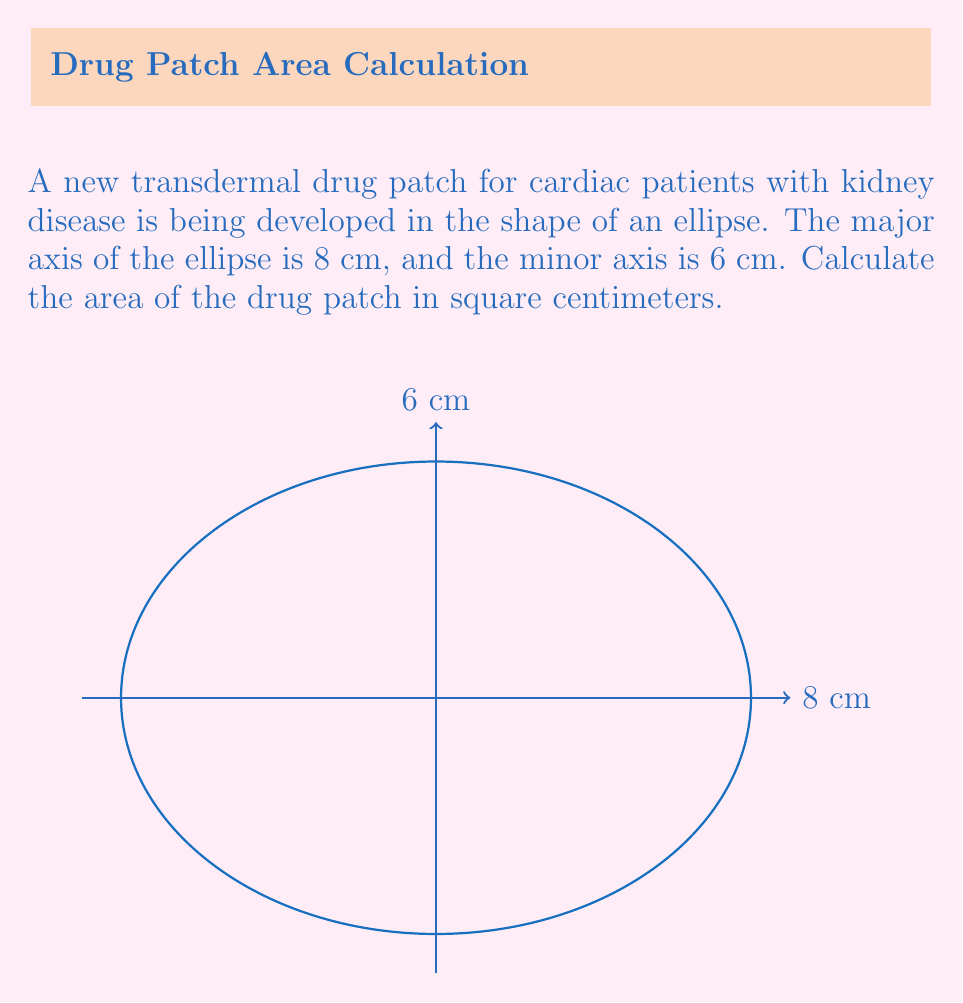Could you help me with this problem? To calculate the area of an ellipse, we use the formula:

$$A = \pi ab$$

Where:
$A$ is the area
$a$ is half the length of the major axis
$b$ is half the length of the minor axis

Given:
- Major axis = 8 cm, so $a = 4$ cm
- Minor axis = 6 cm, so $b = 3$ cm

Step 1: Substitute the values into the formula
$$A = \pi (4)(3)$$

Step 2: Multiply the values inside the parentheses
$$A = \pi (12)$$

Step 3: Multiply by $\pi$
$$A = 12\pi$$

Step 4: Calculate the final value (rounded to two decimal places)
$$A \approx 37.70 \text{ cm}^2$$

This area represents the surface of the drug patch that will be in contact with the patient's skin, determining the amount of medication that can be delivered transdermally.
Answer: $37.70 \text{ cm}^2$ 